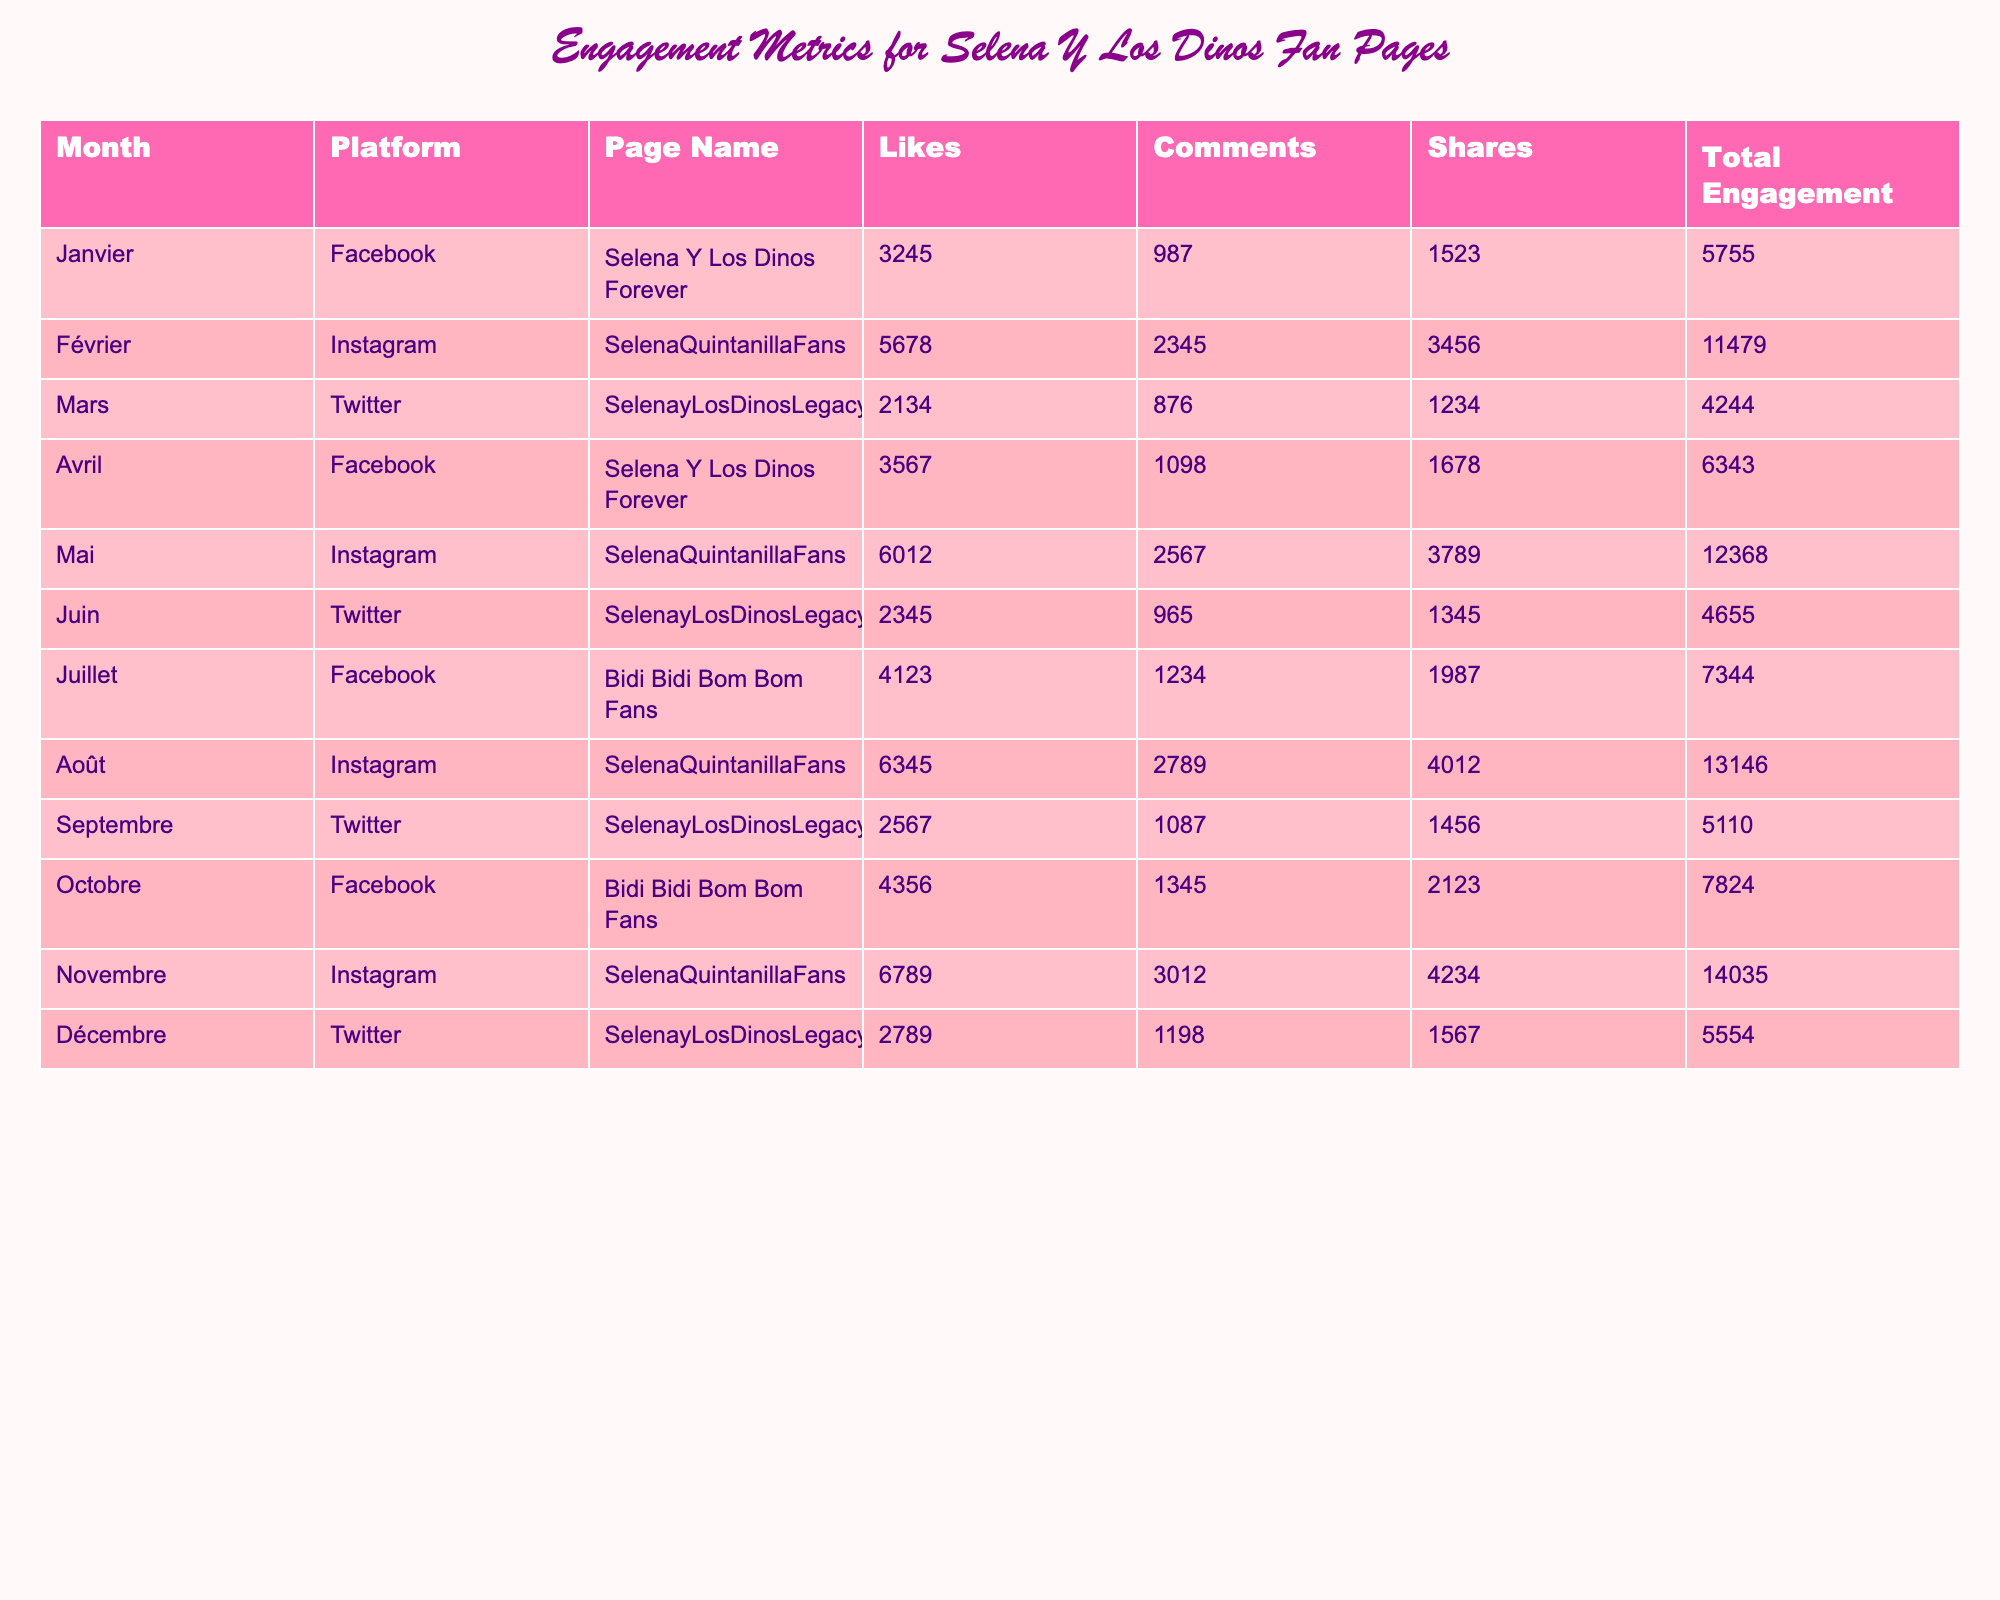Quel est le total d'engagement pour la page "Selena Y Los Dinos Forever" en janvier ? La table montre que pour la page "Selena Y Los Dinos Forever", le total d'engagement en janvier est directement indiqué comme 5755.
Answer: 5755 Quelle plateforme a le plus d'engagement total en novembre ? Pour novembre, en regardant les lignes, la plateforme Instagram pour "SelenaQuintanillaFans" a un engagement total de 14035, ce qui est le maximum comparé aux autres données mensuelles.
Answer: Instagram Quel est le nombre de partages pour la page "SelenayLosDinosLegacy" en mars ? Dans la ligne pour "SelenayLosDinosLegacy" en mars, le nombre de partages est indiqué comme 1234.
Answer: 1234 Quel mois a eu le plus grand total d'engagement et quel était ce total ? En comparant les totaux d'engagement de chaque mois, août avec "SelenaQuintanillaFans" a le plus grand total d’engagement à 13146.
Answer: 13146 Quel est le total d'engagement pour toutes les pages sur Twitter ? En additionnant les totaux d'engagement pour Twitter : 4244 (mars) + 4655 (juin) + 5110 (septembre) + 5554 (décembre) = 21163.
Answer: 21163 Combien de commentaires ont été générés par la page "SelenaQuintanillaFans" en mai et juin combinés ? En mai, le nombre de commentaires est 2567 et en juin il est 965. La somme donne 2567 + 965 = 3532.
Answer: 3532 La page "Bidi Bidi Bom Bom Fans" a-t-elle plus d'engagement en juillet ou en octobre ? En juillet, l'engagement total est 7344, et en octobre il est 7824. Comparant les deux, octobre a un engagement supérieur à juillet.
Answer: Oui Quel est l'engagement total moyen pour toutes les pages sur Instagram ? Les totaux d'engagement pour Instagram sont 11479 (février), 12368 (mai), 13146 (août), et 14035 (novembre), donc la moyenne est (11479 + 12368 + 13146 + 14035) / 4 = 12777.
Answer: 12777 Quelles pages ont eu plus de 5000 engagements totaux au mois de septembre ? En septembre, seule la page "SelenayLosDinosLegacy" a un engagement total de 5110, qui est supérieur à 5000.
Answer: Oui En quelle plateforme et mois y a-t-il eu le moindre engagement total ? En consultant la table, la ligne de "SelenayLosDinosLegacy" en mars a le moindre engagement total de 4244.
Answer: Twitter, mars 